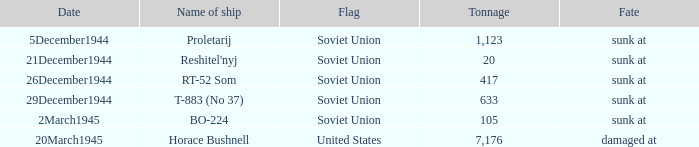What is the mean weight of the vessel called proletarij? 1123.0. 